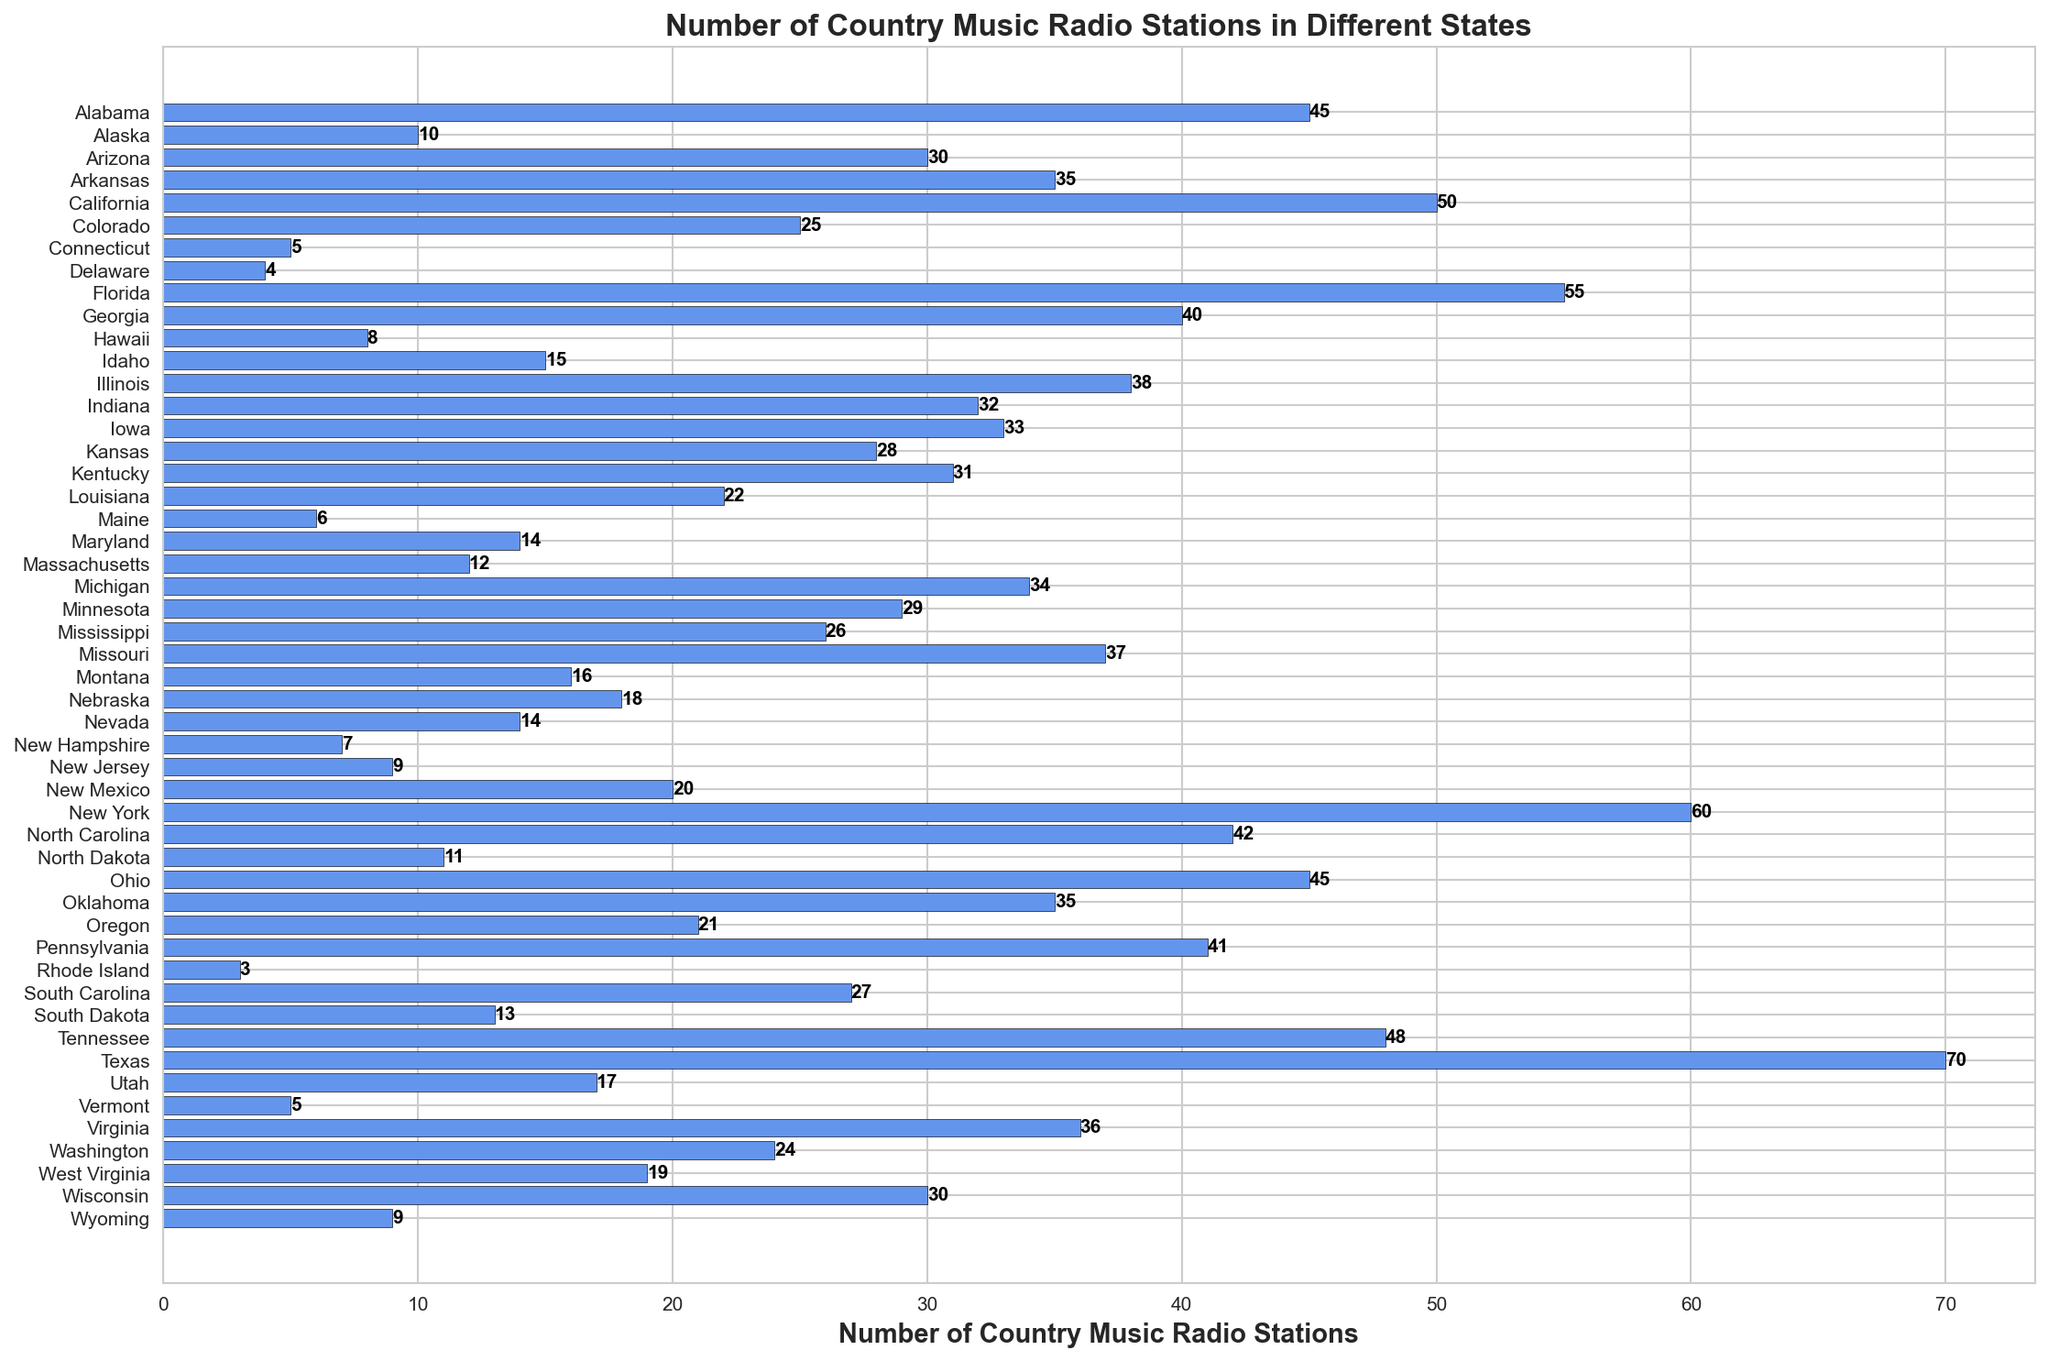How many country music radio stations are there in Texas? Locate the bar representing Texas, and the label next to the bar shows the number of country music stations.
Answer: 70 Which state has more country music radio stations, California or Florida? Find the bars representing California and Florida, and compare their lengths and labels. California has 50 stations, while Florida has 55.
Answer: Florida What is the sum of country music radio stations in New York, Texas, and California? Add the values for New York (60), Texas (70), and California (50). The sum is 60 + 70 + 50 = 180.
Answer: 180 Which state has the least number of country music radio stations? Identify the shortest bar and check its label. Rhode Island has 3 stations, which is the least.
Answer: Rhode Island How many states have more than 40 country music radio stations? Count the bars with labels greater than 40. The states are Florida (55), New York (60), North Carolina (42), Ohio (45), Alabama (45), Tennessee (48), California (50), and Texas (70). There are 8 states in total.
Answer: 8 What is the average number of country music radio stations among Alabama, Georgia, and Tennessee? Sum the values for Alabama (45), Georgia (40), and Tennessee (48). Divide the sum by 3. (45 + 40 + 48) / 3 = 44.33.
Answer: 44.33 Which state has exactly 15 country music radio stations? Locate the bar with a label of 15, which corresponds to Idaho.
Answer: Idaho How many more country music radio stations does Florida have compared to Michigan? Subtract the number of stations in Michigan (34) from the number in Florida (55). 55 - 34 = 21.
Answer: 21 Which states have between 10 and 20 country music radio stations? Identify the bars with labels between 10 and 20. The states are Alaska (10), Hawaii (8), Idaho (15), Louisiana (22), Maryland (14), Massachusetts (12), Montana (16), Nevada (14), South Dakota (13), New Hampshire (7), Vermont (5), North Dakota (11), Utah (17), and West Virginia (19).
Answer: Alaska, Hawaii, Idaho, Maryland, Massachusetts, Montana, Nevada, New Hampshire, North Dakota, South Dakota, Utah, Vermont, West Virginia What is the difference in the number of country music radio stations between the state with the most and the state with the least number of stations? The state with the most stations is Texas (70) and the state with the least is Rhode Island (3). The difference is 70 - 3 = 67.
Answer: 67 